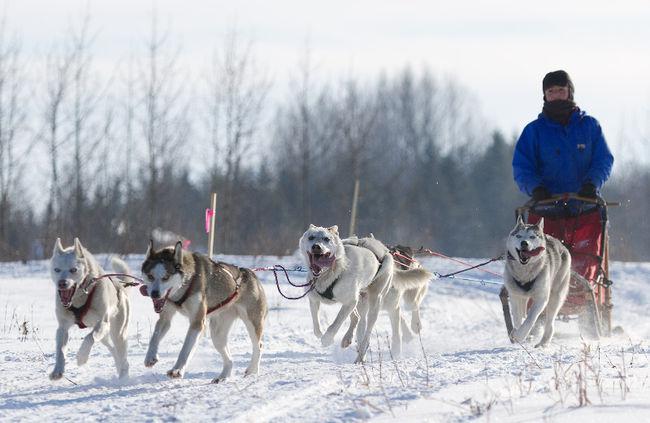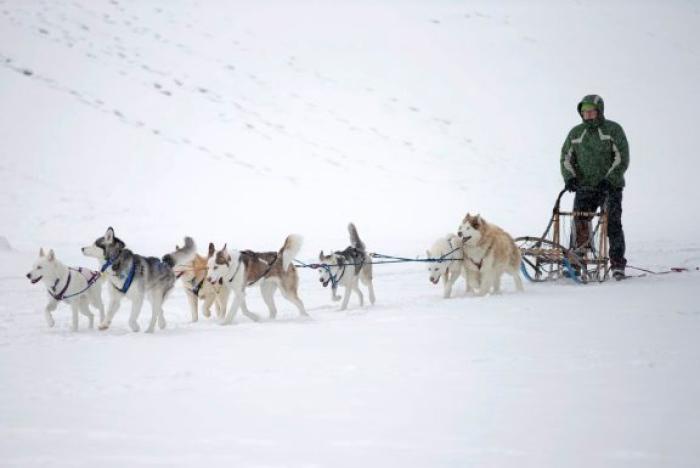The first image is the image on the left, the second image is the image on the right. Examine the images to the left and right. Is the description "One of the people on the sleds is wearing a bright blue coat." accurate? Answer yes or no. Yes. The first image is the image on the left, the second image is the image on the right. Assess this claim about the two images: "In at least one image there are at least two people being pulled by at least 6 sled dogs.". Correct or not? Answer yes or no. No. 